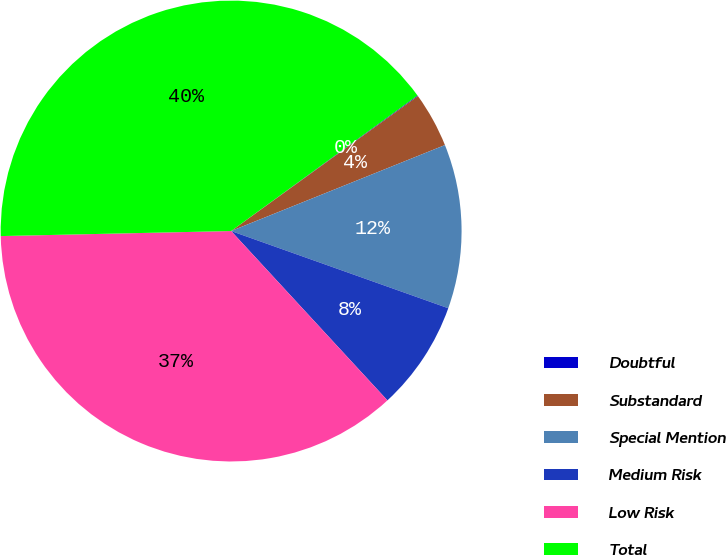Convert chart to OTSL. <chart><loc_0><loc_0><loc_500><loc_500><pie_chart><fcel>Doubtful<fcel>Substandard<fcel>Special Mention<fcel>Medium Risk<fcel>Low Risk<fcel>Total<nl><fcel>0.05%<fcel>3.87%<fcel>11.52%<fcel>7.7%<fcel>36.51%<fcel>40.34%<nl></chart> 